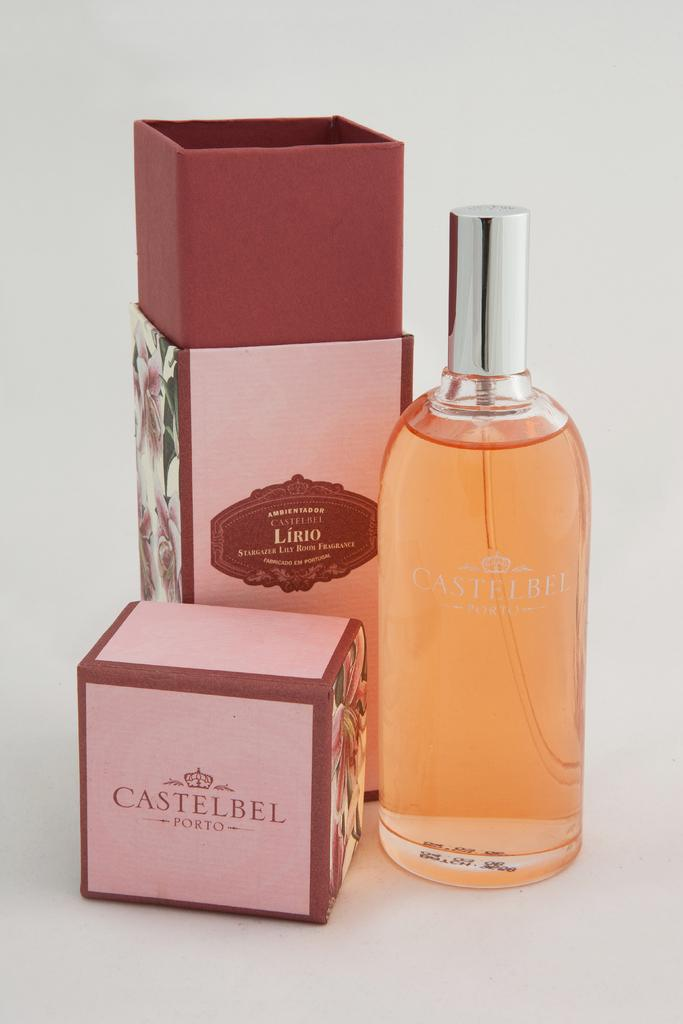<image>
Share a concise interpretation of the image provided. a bottle of Castelbel standing next to its box 